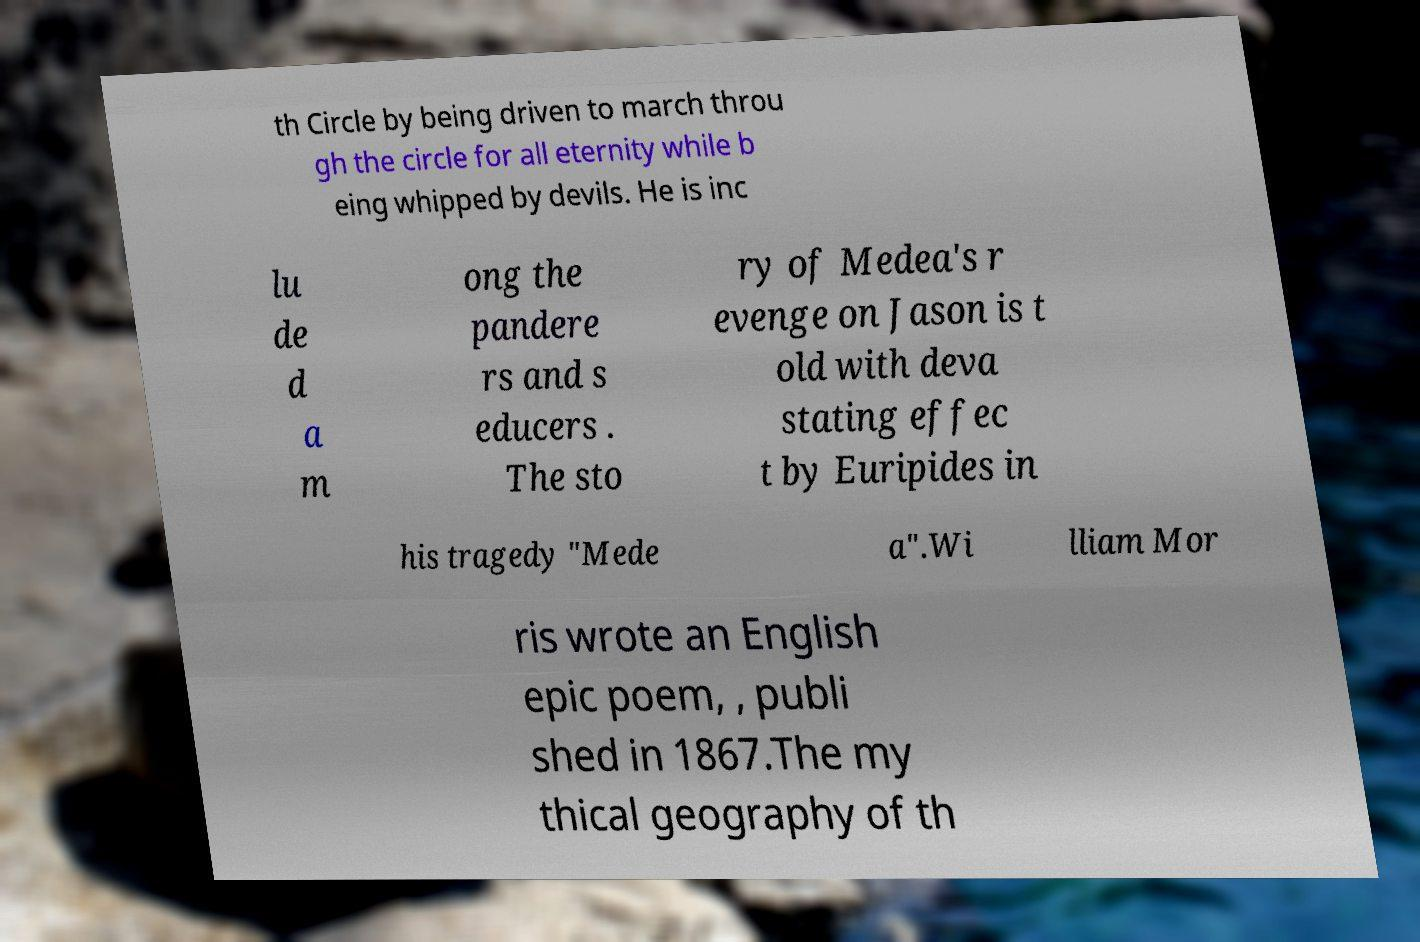Can you read and provide the text displayed in the image?This photo seems to have some interesting text. Can you extract and type it out for me? th Circle by being driven to march throu gh the circle for all eternity while b eing whipped by devils. He is inc lu de d a m ong the pandere rs and s educers . The sto ry of Medea's r evenge on Jason is t old with deva stating effec t by Euripides in his tragedy "Mede a".Wi lliam Mor ris wrote an English epic poem, , publi shed in 1867.The my thical geography of th 